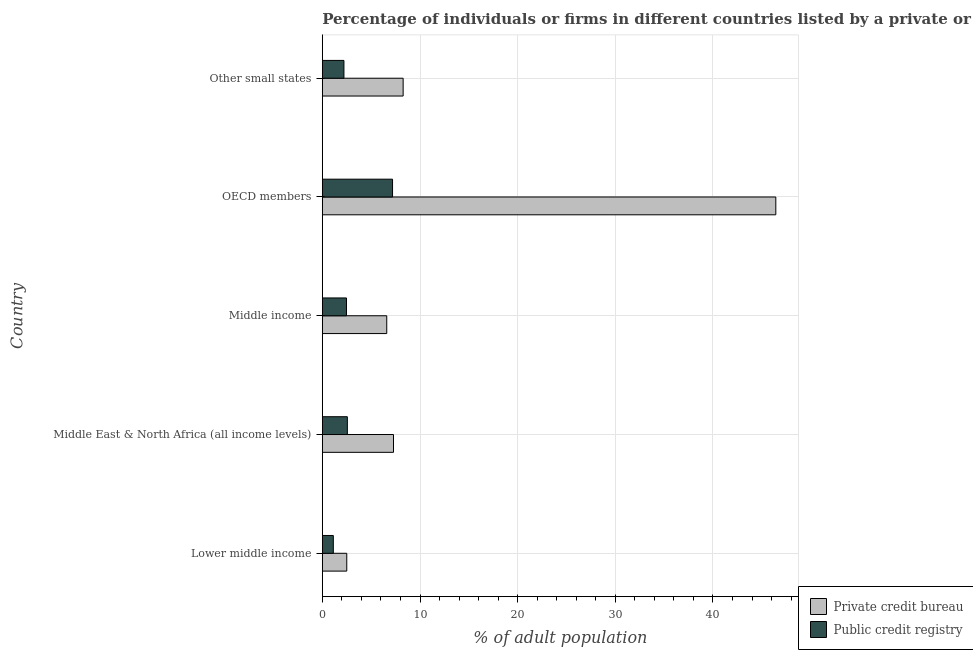How many different coloured bars are there?
Provide a succinct answer. 2. How many groups of bars are there?
Ensure brevity in your answer.  5. Are the number of bars per tick equal to the number of legend labels?
Provide a short and direct response. Yes. Are the number of bars on each tick of the Y-axis equal?
Keep it short and to the point. Yes. How many bars are there on the 4th tick from the top?
Provide a succinct answer. 2. How many bars are there on the 2nd tick from the bottom?
Ensure brevity in your answer.  2. In how many cases, is the number of bars for a given country not equal to the number of legend labels?
Offer a very short reply. 0. What is the percentage of firms listed by public credit bureau in Lower middle income?
Offer a terse response. 1.12. Across all countries, what is the maximum percentage of firms listed by private credit bureau?
Offer a terse response. 46.43. Across all countries, what is the minimum percentage of firms listed by private credit bureau?
Your response must be concise. 2.5. In which country was the percentage of firms listed by public credit bureau maximum?
Provide a succinct answer. OECD members. In which country was the percentage of firms listed by public credit bureau minimum?
Offer a terse response. Lower middle income. What is the total percentage of firms listed by private credit bureau in the graph?
Provide a succinct answer. 71.09. What is the difference between the percentage of firms listed by private credit bureau in Middle income and that in Other small states?
Provide a succinct answer. -1.68. What is the difference between the percentage of firms listed by private credit bureau in OECD members and the percentage of firms listed by public credit bureau in Middle East & North Africa (all income levels)?
Give a very brief answer. 43.87. What is the average percentage of firms listed by public credit bureau per country?
Make the answer very short. 3.11. What is the difference between the percentage of firms listed by public credit bureau and percentage of firms listed by private credit bureau in Middle income?
Offer a very short reply. -4.12. What is the difference between the highest and the second highest percentage of firms listed by private credit bureau?
Provide a short and direct response. 38.16. What is the difference between the highest and the lowest percentage of firms listed by public credit bureau?
Keep it short and to the point. 6.06. Is the sum of the percentage of firms listed by public credit bureau in Middle East & North Africa (all income levels) and Middle income greater than the maximum percentage of firms listed by private credit bureau across all countries?
Offer a terse response. No. What does the 1st bar from the top in Middle East & North Africa (all income levels) represents?
Keep it short and to the point. Public credit registry. What does the 1st bar from the bottom in Middle income represents?
Your answer should be very brief. Private credit bureau. How many countries are there in the graph?
Give a very brief answer. 5. Does the graph contain grids?
Offer a terse response. Yes. How many legend labels are there?
Give a very brief answer. 2. What is the title of the graph?
Make the answer very short. Percentage of individuals or firms in different countries listed by a private or public credit bureau. Does "Start a business" appear as one of the legend labels in the graph?
Your answer should be compact. No. What is the label or title of the X-axis?
Provide a short and direct response. % of adult population. What is the % of adult population of Private credit bureau in Lower middle income?
Your answer should be compact. 2.5. What is the % of adult population in Private credit bureau in Middle East & North Africa (all income levels)?
Ensure brevity in your answer.  7.29. What is the % of adult population of Public credit registry in Middle East & North Africa (all income levels)?
Your answer should be compact. 2.56. What is the % of adult population of Private credit bureau in Middle income?
Offer a very short reply. 6.6. What is the % of adult population in Public credit registry in Middle income?
Offer a very short reply. 2.47. What is the % of adult population of Private credit bureau in OECD members?
Your answer should be compact. 46.43. What is the % of adult population of Public credit registry in OECD members?
Make the answer very short. 7.19. What is the % of adult population of Private credit bureau in Other small states?
Your response must be concise. 8.28. What is the % of adult population of Public credit registry in Other small states?
Give a very brief answer. 2.21. Across all countries, what is the maximum % of adult population in Private credit bureau?
Ensure brevity in your answer.  46.43. Across all countries, what is the maximum % of adult population of Public credit registry?
Provide a succinct answer. 7.19. Across all countries, what is the minimum % of adult population in Private credit bureau?
Your answer should be compact. 2.5. What is the total % of adult population of Private credit bureau in the graph?
Make the answer very short. 71.09. What is the total % of adult population in Public credit registry in the graph?
Offer a terse response. 15.56. What is the difference between the % of adult population in Private credit bureau in Lower middle income and that in Middle East & North Africa (all income levels)?
Ensure brevity in your answer.  -4.79. What is the difference between the % of adult population of Public credit registry in Lower middle income and that in Middle East & North Africa (all income levels)?
Give a very brief answer. -1.44. What is the difference between the % of adult population in Private credit bureau in Lower middle income and that in Middle income?
Your answer should be compact. -4.09. What is the difference between the % of adult population of Public credit registry in Lower middle income and that in Middle income?
Provide a succinct answer. -1.35. What is the difference between the % of adult population of Private credit bureau in Lower middle income and that in OECD members?
Your answer should be compact. -43.93. What is the difference between the % of adult population of Public credit registry in Lower middle income and that in OECD members?
Provide a succinct answer. -6.07. What is the difference between the % of adult population in Private credit bureau in Lower middle income and that in Other small states?
Offer a terse response. -5.77. What is the difference between the % of adult population in Public credit registry in Lower middle income and that in Other small states?
Your answer should be compact. -1.09. What is the difference between the % of adult population in Private credit bureau in Middle East & North Africa (all income levels) and that in Middle income?
Your response must be concise. 0.69. What is the difference between the % of adult population of Public credit registry in Middle East & North Africa (all income levels) and that in Middle income?
Provide a short and direct response. 0.09. What is the difference between the % of adult population in Private credit bureau in Middle East & North Africa (all income levels) and that in OECD members?
Your response must be concise. -39.15. What is the difference between the % of adult population of Public credit registry in Middle East & North Africa (all income levels) and that in OECD members?
Your response must be concise. -4.63. What is the difference between the % of adult population of Private credit bureau in Middle East & North Africa (all income levels) and that in Other small states?
Keep it short and to the point. -0.99. What is the difference between the % of adult population of Private credit bureau in Middle income and that in OECD members?
Offer a terse response. -39.84. What is the difference between the % of adult population of Public credit registry in Middle income and that in OECD members?
Make the answer very short. -4.72. What is the difference between the % of adult population in Private credit bureau in Middle income and that in Other small states?
Give a very brief answer. -1.68. What is the difference between the % of adult population of Public credit registry in Middle income and that in Other small states?
Provide a short and direct response. 0.26. What is the difference between the % of adult population in Private credit bureau in OECD members and that in Other small states?
Offer a very short reply. 38.16. What is the difference between the % of adult population of Public credit registry in OECD members and that in Other small states?
Make the answer very short. 4.98. What is the difference between the % of adult population of Private credit bureau in Lower middle income and the % of adult population of Public credit registry in Middle East & North Africa (all income levels)?
Keep it short and to the point. -0.06. What is the difference between the % of adult population of Private credit bureau in Lower middle income and the % of adult population of Public credit registry in Middle income?
Offer a terse response. 0.03. What is the difference between the % of adult population of Private credit bureau in Lower middle income and the % of adult population of Public credit registry in OECD members?
Your response must be concise. -4.69. What is the difference between the % of adult population of Private credit bureau in Lower middle income and the % of adult population of Public credit registry in Other small states?
Provide a short and direct response. 0.29. What is the difference between the % of adult population in Private credit bureau in Middle East & North Africa (all income levels) and the % of adult population in Public credit registry in Middle income?
Ensure brevity in your answer.  4.81. What is the difference between the % of adult population in Private credit bureau in Middle East & North Africa (all income levels) and the % of adult population in Public credit registry in OECD members?
Offer a terse response. 0.1. What is the difference between the % of adult population in Private credit bureau in Middle East & North Africa (all income levels) and the % of adult population in Public credit registry in Other small states?
Offer a very short reply. 5.08. What is the difference between the % of adult population of Private credit bureau in Middle income and the % of adult population of Public credit registry in OECD members?
Keep it short and to the point. -0.59. What is the difference between the % of adult population of Private credit bureau in Middle income and the % of adult population of Public credit registry in Other small states?
Ensure brevity in your answer.  4.38. What is the difference between the % of adult population of Private credit bureau in OECD members and the % of adult population of Public credit registry in Other small states?
Provide a short and direct response. 44.22. What is the average % of adult population of Private credit bureau per country?
Your response must be concise. 14.22. What is the average % of adult population of Public credit registry per country?
Your answer should be compact. 3.11. What is the difference between the % of adult population in Private credit bureau and % of adult population in Public credit registry in Lower middle income?
Provide a succinct answer. 1.38. What is the difference between the % of adult population in Private credit bureau and % of adult population in Public credit registry in Middle East & North Africa (all income levels)?
Ensure brevity in your answer.  4.72. What is the difference between the % of adult population of Private credit bureau and % of adult population of Public credit registry in Middle income?
Your answer should be compact. 4.12. What is the difference between the % of adult population of Private credit bureau and % of adult population of Public credit registry in OECD members?
Offer a terse response. 39.24. What is the difference between the % of adult population of Private credit bureau and % of adult population of Public credit registry in Other small states?
Offer a terse response. 6.06. What is the ratio of the % of adult population of Private credit bureau in Lower middle income to that in Middle East & North Africa (all income levels)?
Provide a succinct answer. 0.34. What is the ratio of the % of adult population of Public credit registry in Lower middle income to that in Middle East & North Africa (all income levels)?
Offer a terse response. 0.44. What is the ratio of the % of adult population of Private credit bureau in Lower middle income to that in Middle income?
Keep it short and to the point. 0.38. What is the ratio of the % of adult population in Public credit registry in Lower middle income to that in Middle income?
Offer a terse response. 0.45. What is the ratio of the % of adult population in Private credit bureau in Lower middle income to that in OECD members?
Your answer should be compact. 0.05. What is the ratio of the % of adult population in Public credit registry in Lower middle income to that in OECD members?
Make the answer very short. 0.16. What is the ratio of the % of adult population of Private credit bureau in Lower middle income to that in Other small states?
Your response must be concise. 0.3. What is the ratio of the % of adult population of Public credit registry in Lower middle income to that in Other small states?
Provide a succinct answer. 0.51. What is the ratio of the % of adult population in Private credit bureau in Middle East & North Africa (all income levels) to that in Middle income?
Provide a succinct answer. 1.1. What is the ratio of the % of adult population in Public credit registry in Middle East & North Africa (all income levels) to that in Middle income?
Your answer should be compact. 1.04. What is the ratio of the % of adult population in Private credit bureau in Middle East & North Africa (all income levels) to that in OECD members?
Give a very brief answer. 0.16. What is the ratio of the % of adult population of Public credit registry in Middle East & North Africa (all income levels) to that in OECD members?
Keep it short and to the point. 0.36. What is the ratio of the % of adult population in Private credit bureau in Middle East & North Africa (all income levels) to that in Other small states?
Provide a succinct answer. 0.88. What is the ratio of the % of adult population of Public credit registry in Middle East & North Africa (all income levels) to that in Other small states?
Provide a succinct answer. 1.16. What is the ratio of the % of adult population of Private credit bureau in Middle income to that in OECD members?
Give a very brief answer. 0.14. What is the ratio of the % of adult population of Public credit registry in Middle income to that in OECD members?
Your answer should be compact. 0.34. What is the ratio of the % of adult population in Private credit bureau in Middle income to that in Other small states?
Provide a short and direct response. 0.8. What is the ratio of the % of adult population of Public credit registry in Middle income to that in Other small states?
Offer a very short reply. 1.12. What is the ratio of the % of adult population of Private credit bureau in OECD members to that in Other small states?
Offer a very short reply. 5.61. What is the ratio of the % of adult population in Public credit registry in OECD members to that in Other small states?
Ensure brevity in your answer.  3.25. What is the difference between the highest and the second highest % of adult population of Private credit bureau?
Offer a very short reply. 38.16. What is the difference between the highest and the second highest % of adult population of Public credit registry?
Make the answer very short. 4.63. What is the difference between the highest and the lowest % of adult population in Private credit bureau?
Keep it short and to the point. 43.93. What is the difference between the highest and the lowest % of adult population of Public credit registry?
Keep it short and to the point. 6.07. 